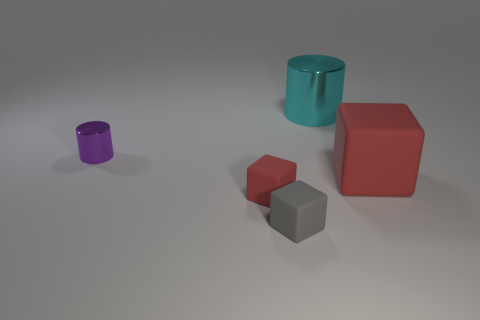Add 4 large purple matte balls. How many objects exist? 9 Subtract all cylinders. How many objects are left? 3 Subtract all big cylinders. Subtract all big shiny cylinders. How many objects are left? 3 Add 3 small red things. How many small red things are left? 4 Add 3 big cyan cylinders. How many big cyan cylinders exist? 4 Subtract 0 gray cylinders. How many objects are left? 5 